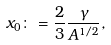<formula> <loc_0><loc_0><loc_500><loc_500>x _ { 0 } \colon = \frac { 2 } { 3 } \frac { \gamma } { A ^ { 1 / 2 } } ,</formula> 